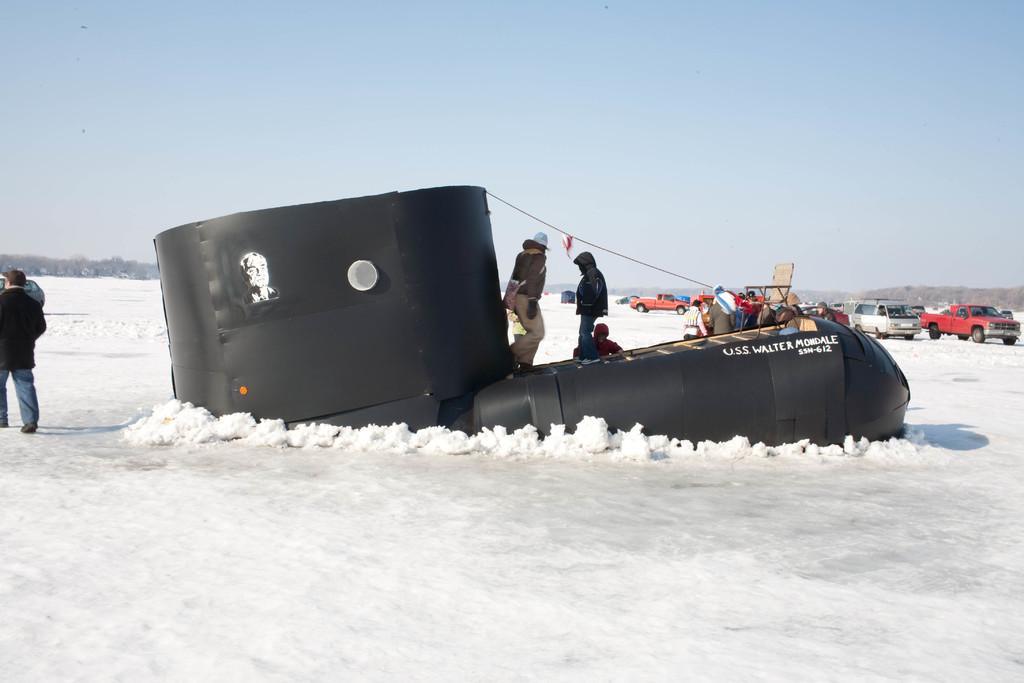In one or two sentences, can you explain what this image depicts? In this image, we can see black submarine made with sheets on the snow. On this submarine, we can see two persons, chair and few objects. In the background, there are trees, people, vehicles and the sky. On the left side of the image, a person walking on the snow. 